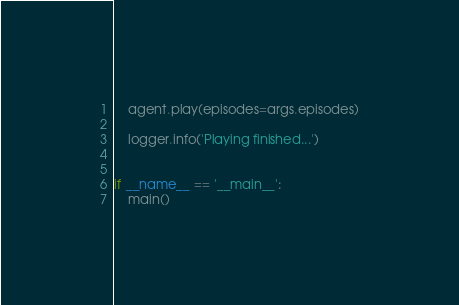<code> <loc_0><loc_0><loc_500><loc_500><_Python_>    agent.play(episodes=args.episodes)

    logger.info('Playing finished...')


if __name__ == '__main__':
    main()
</code> 